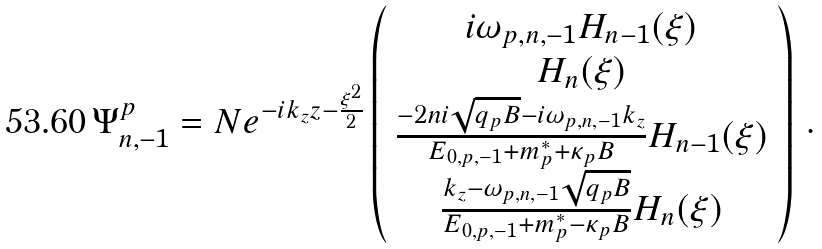<formula> <loc_0><loc_0><loc_500><loc_500>\Psi ^ { p } _ { n , - 1 } = N e ^ { - i k _ { z } z - \frac { \xi ^ { 2 } } { 2 } } \left ( \begin{array} { c } i \omega _ { p , n , - 1 } H _ { n - 1 } ( \xi ) \\ H _ { n } ( \xi ) \\ \frac { - 2 n i \sqrt { q _ { p } B } - i \omega _ { p , n , - 1 } k _ { z } } { E _ { 0 , p , - 1 } + m _ { p } ^ { * } + \kappa _ { p } B } H _ { n - 1 } ( \xi ) \\ \frac { k _ { z } - \omega _ { p , n , - 1 } \sqrt { q _ { p } B } } { E _ { 0 , p , - 1 } + m _ { p } ^ { * } - \kappa _ { p } B } H _ { n } ( \xi ) \end{array} \right ) \, .</formula> 